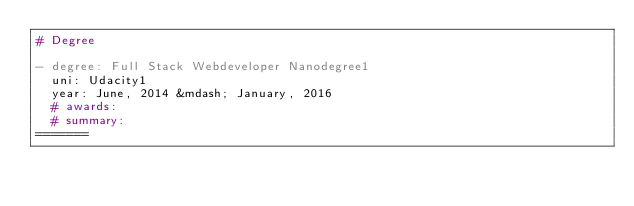Convert code to text. <code><loc_0><loc_0><loc_500><loc_500><_YAML_># Degree

- degree: Full Stack Webdeveloper Nanodegree1  
  uni: Udacity1
  year: June, 2014 &mdash; January, 2016
  # awards:
  # summary:
=======
</code> 